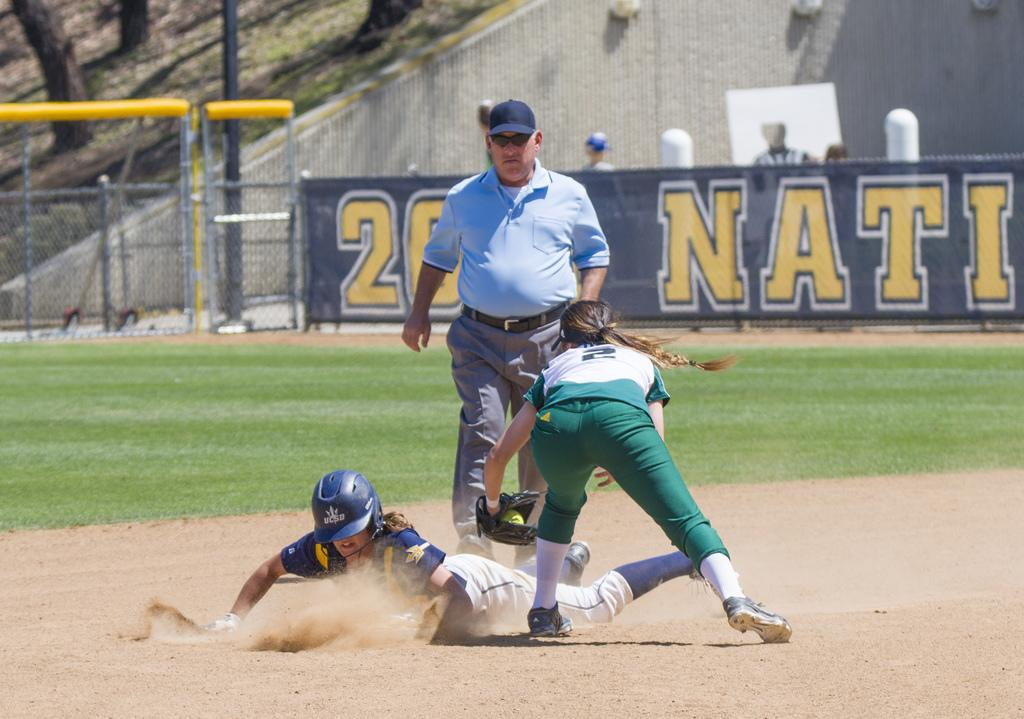<image>
Present a compact description of the photo's key features. A UCSD softball player slides into a base in a cloud of dust. 